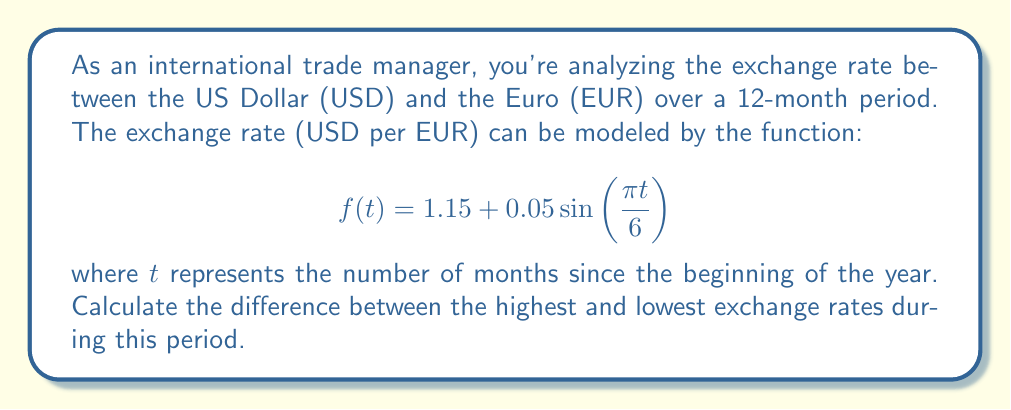What is the answer to this math problem? To solve this problem, we need to follow these steps:

1) First, we need to find the maximum and minimum values of the function $f(t)$ over the given period.

2) The function $f(t)$ is a sinusoidal function with a vertical shift of 1.15 and an amplitude of 0.05.

3) The maximum value of sine function is 1, and its minimum value is -1.

4) Therefore, the maximum value of $f(t)$ occurs when $\sin\left(\frac{\pi t}{6}\right) = 1$:

   $$f_{max} = 1.15 + 0.05(1) = 1.20$$

5) The minimum value of $f(t)$ occurs when $\sin\left(\frac{\pi t}{6}\right) = -1$:

   $$f_{min} = 1.15 + 0.05(-1) = 1.10$$

6) The difference between the highest and lowest exchange rates is:

   $$f_{max} - f_{min} = 1.20 - 1.10 = 0.10$$

Thus, the difference between the highest and lowest exchange rates during this 12-month period is 0.10 USD per EUR.
Answer: 0.10 USD/EUR 